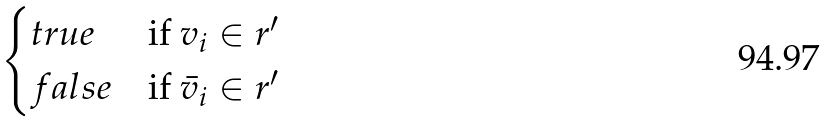Convert formula to latex. <formula><loc_0><loc_0><loc_500><loc_500>\begin{cases} t r u e & \text {if $v_{i} \in r^{\prime}$} \\ f a l s e & \text {if $\bar{v}_{i} \in r^{\prime}$} \end{cases}</formula> 